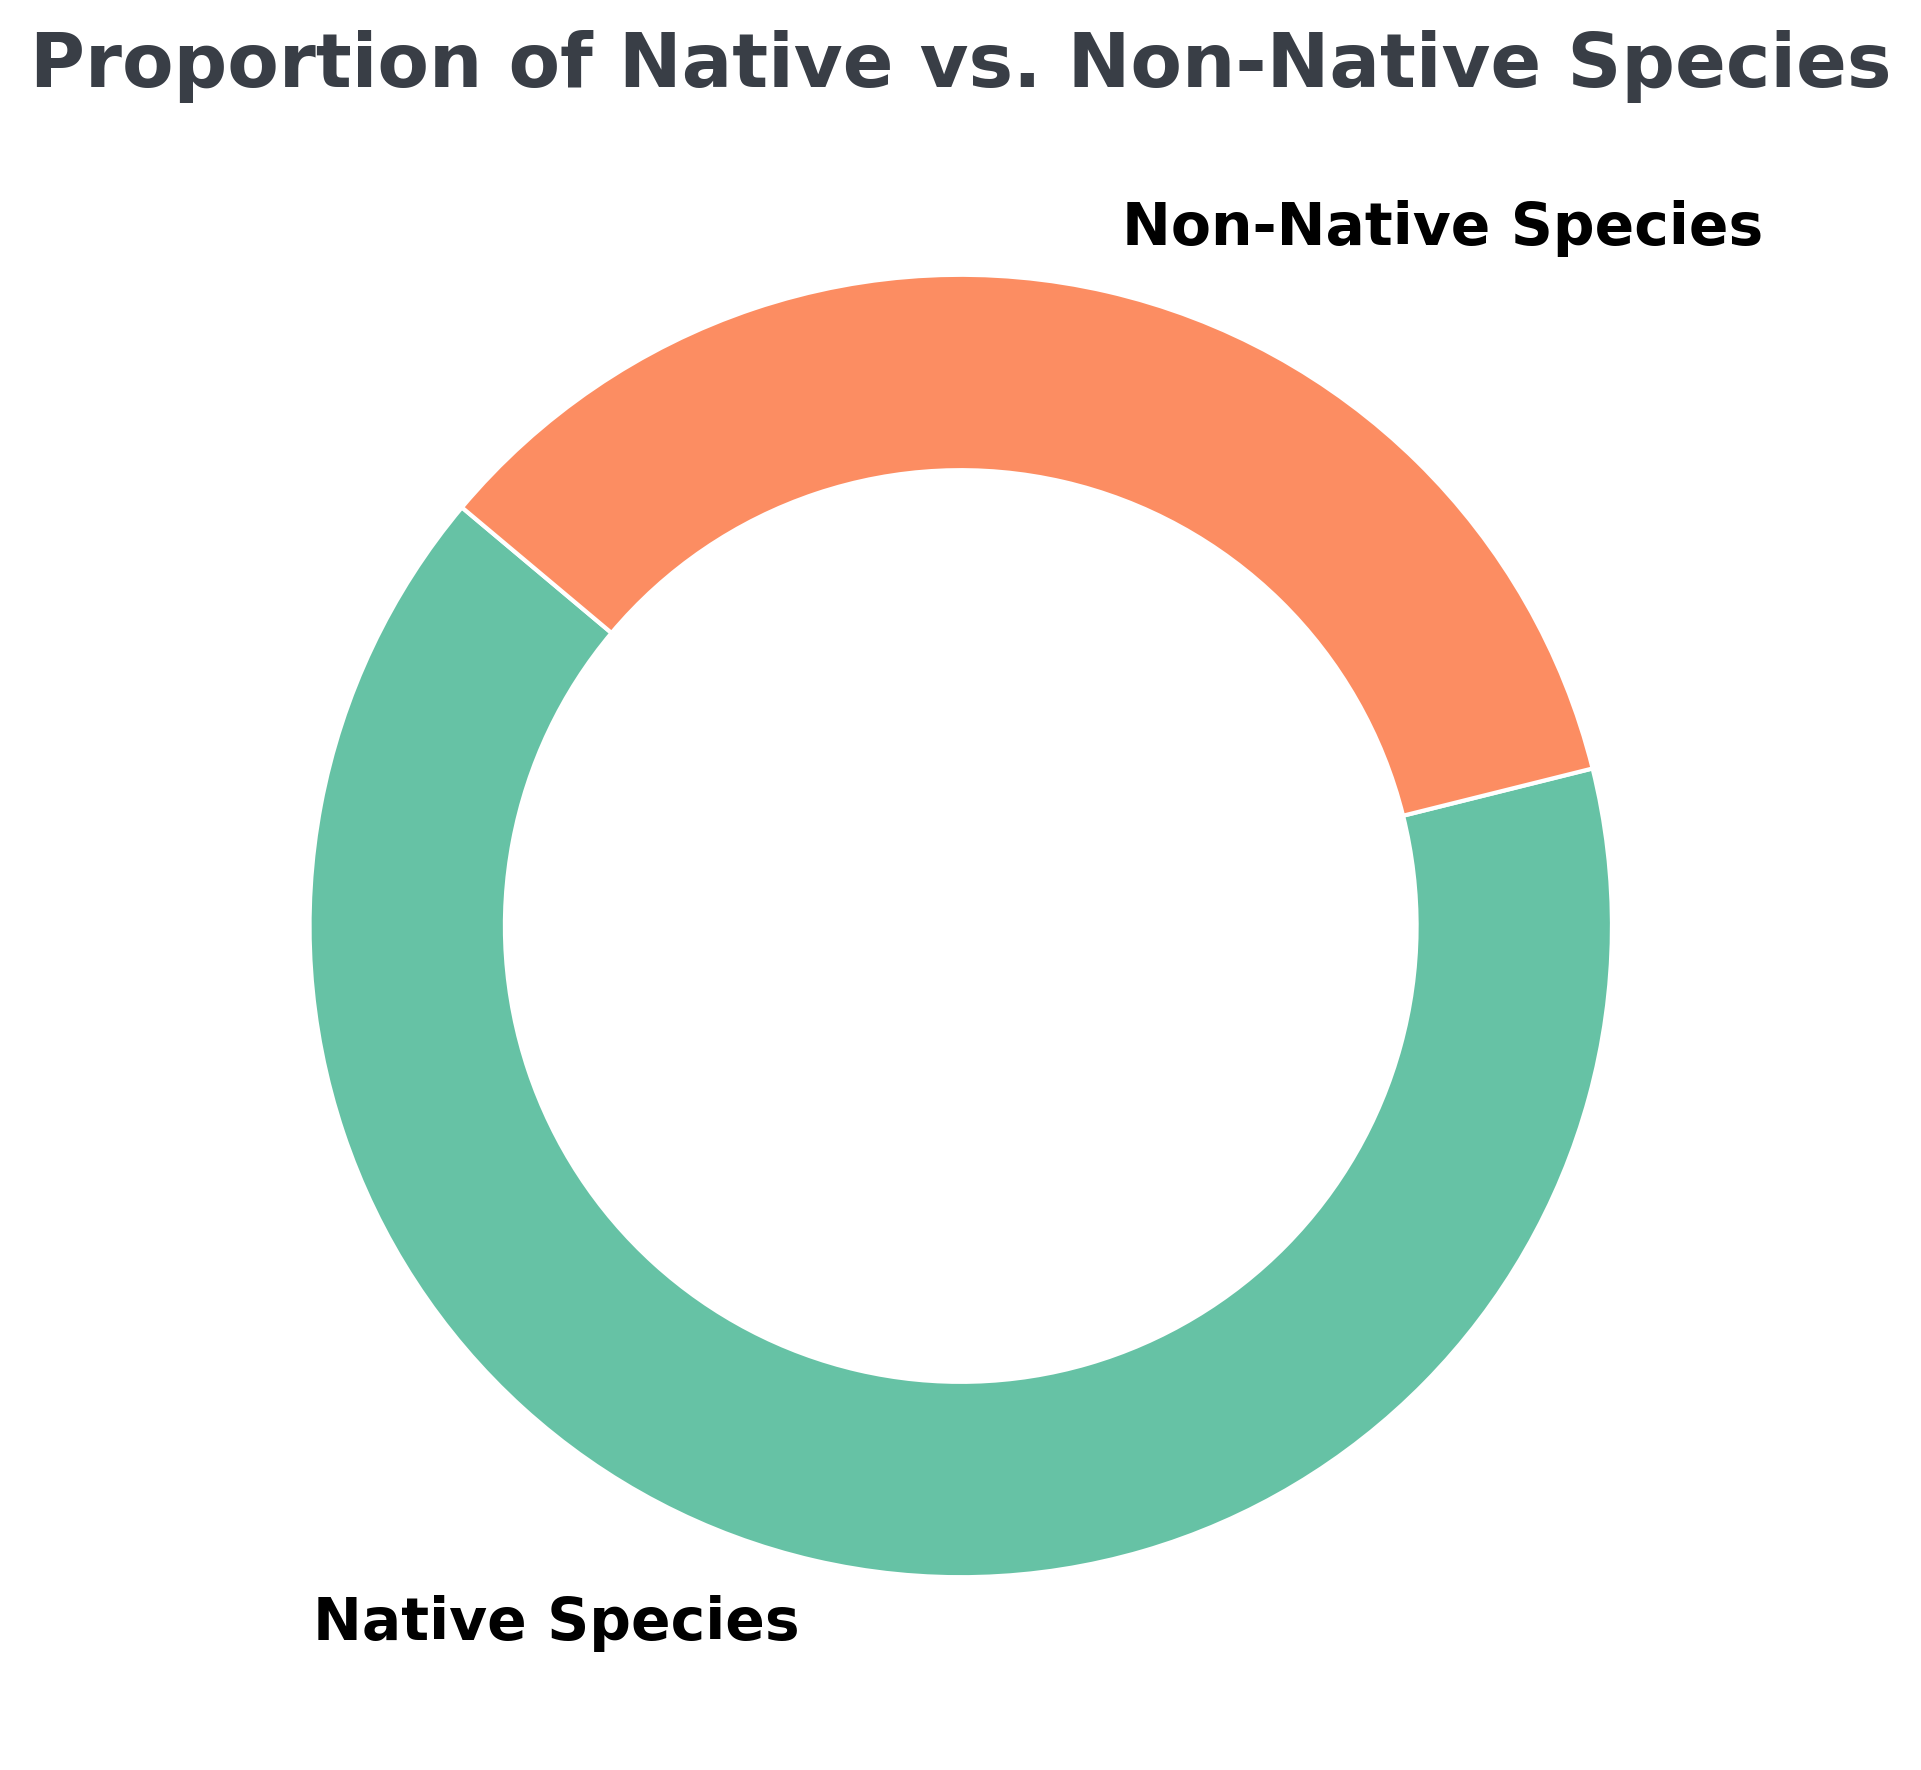What percentage of species are native in the ecosystem? The pie chart shows that the proportion of native species is 65%. This value is explicitly written in the chart.
Answer: 65% What percentage of species are non-native in the ecosystem? The pie chart indicates that the proportion of non-native species is 35%, as shown directly in the figure.
Answer: 35% Which category has a higher proportion, native species or non-native species? By comparing the percentages given, native species have 65% while non-native species have 35%. 65% is greater than 35%.
Answer: Native species What is the difference in percentage between native and non-native species in the ecosystem? Native species make up 65% and non-native species make up 35%. The difference is calculated as 65% - 35%.
Answer: 30% What fraction of the species in the ecosystem are native? The pie chart indicates that 65% of the species are native. This can be converted into a fraction by dividing 65 by 100.
Answer: 65/100 or 13/20 Are native species more than twice as abundant as non-native species in this ecosystem? Native species are 65% and non-native species are 35%. Twice 35% is 70%. Since 65% is less than 70%, native species are not more than twice as abundant.
Answer: No What percentage of the species are NOT native? The pie chart shows that non-native species account for 35% of the ecosystem. This value represents the species that are not native.
Answer: 35% If the total number of species observed is 1000, how many are expected to be non-native? Given that the proportion of non-native species is 35%, we calculate the number by multiplying 1000 by 0.35. So, 1000 * 0.35 = 350.
Answer: 350 species If the total number of species increases by 200, and the proportions stay the same, how many native species will there be in the ecosystem? Initially, the total number of species is 1000. With an increase of 200, the new total is 1200. With the native species proportion at 65%, the number of native species would be 1200 * 0.65. So, 1200 * 0.65 = 780.
Answer: 780 species 